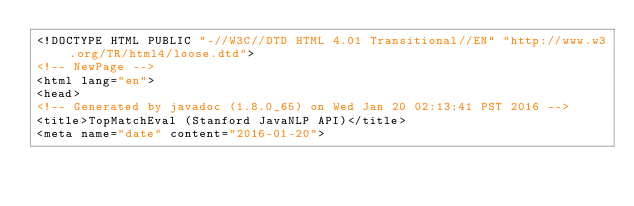Convert code to text. <code><loc_0><loc_0><loc_500><loc_500><_HTML_><!DOCTYPE HTML PUBLIC "-//W3C//DTD HTML 4.01 Transitional//EN" "http://www.w3.org/TR/html4/loose.dtd">
<!-- NewPage -->
<html lang="en">
<head>
<!-- Generated by javadoc (1.8.0_65) on Wed Jan 20 02:13:41 PST 2016 -->
<title>TopMatchEval (Stanford JavaNLP API)</title>
<meta name="date" content="2016-01-20"></code> 